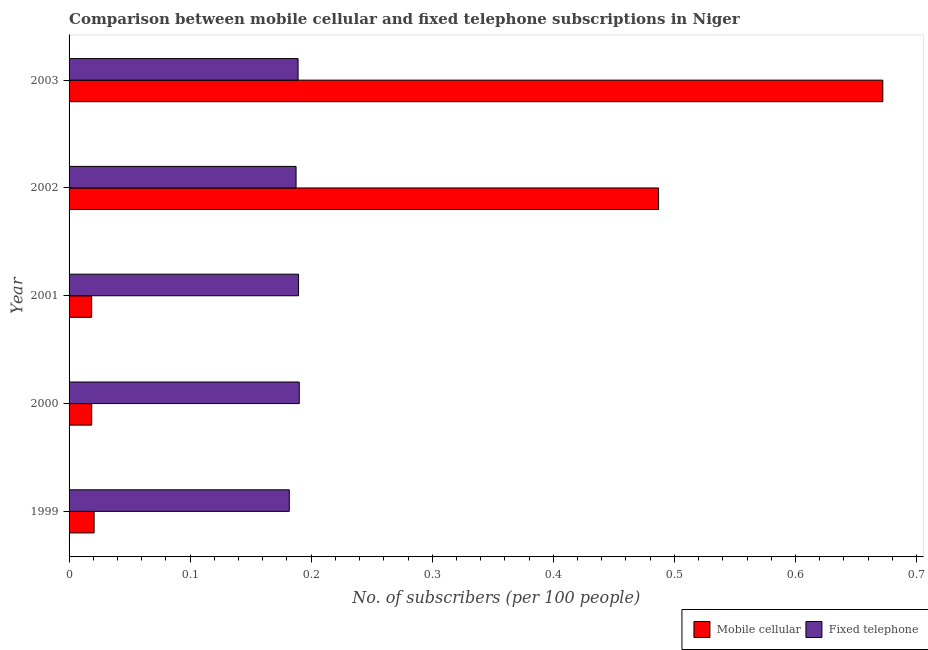How many different coloured bars are there?
Your response must be concise. 2. Are the number of bars per tick equal to the number of legend labels?
Offer a terse response. Yes. Are the number of bars on each tick of the Y-axis equal?
Provide a short and direct response. Yes. How many bars are there on the 2nd tick from the top?
Your response must be concise. 2. In how many cases, is the number of bars for a given year not equal to the number of legend labels?
Make the answer very short. 0. What is the number of fixed telephone subscribers in 2002?
Offer a terse response. 0.19. Across all years, what is the maximum number of fixed telephone subscribers?
Your response must be concise. 0.19. Across all years, what is the minimum number of fixed telephone subscribers?
Your response must be concise. 0.18. In which year was the number of fixed telephone subscribers maximum?
Your answer should be compact. 2000. What is the total number of fixed telephone subscribers in the graph?
Provide a succinct answer. 0.94. What is the difference between the number of fixed telephone subscribers in 1999 and that in 2002?
Your answer should be very brief. -0.01. What is the difference between the number of mobile cellular subscribers in 2002 and the number of fixed telephone subscribers in 2003?
Provide a short and direct response. 0.3. What is the average number of fixed telephone subscribers per year?
Give a very brief answer. 0.19. In the year 1999, what is the difference between the number of mobile cellular subscribers and number of fixed telephone subscribers?
Your answer should be very brief. -0.16. What is the ratio of the number of fixed telephone subscribers in 2001 to that in 2002?
Your response must be concise. 1.01. Is the difference between the number of fixed telephone subscribers in 2000 and 2001 greater than the difference between the number of mobile cellular subscribers in 2000 and 2001?
Your response must be concise. Yes. What is the difference between the highest and the second highest number of fixed telephone subscribers?
Provide a short and direct response. 0. What is the difference between the highest and the lowest number of mobile cellular subscribers?
Offer a terse response. 0.65. In how many years, is the number of fixed telephone subscribers greater than the average number of fixed telephone subscribers taken over all years?
Offer a very short reply. 3. What does the 1st bar from the top in 2003 represents?
Offer a very short reply. Fixed telephone. What does the 2nd bar from the bottom in 2000 represents?
Provide a short and direct response. Fixed telephone. Are all the bars in the graph horizontal?
Make the answer very short. Yes. What is the difference between two consecutive major ticks on the X-axis?
Provide a short and direct response. 0.1. Are the values on the major ticks of X-axis written in scientific E-notation?
Your answer should be compact. No. How many legend labels are there?
Offer a very short reply. 2. What is the title of the graph?
Give a very brief answer. Comparison between mobile cellular and fixed telephone subscriptions in Niger. Does "GDP" appear as one of the legend labels in the graph?
Offer a terse response. No. What is the label or title of the X-axis?
Offer a very short reply. No. of subscribers (per 100 people). What is the label or title of the Y-axis?
Provide a succinct answer. Year. What is the No. of subscribers (per 100 people) in Mobile cellular in 1999?
Give a very brief answer. 0.02. What is the No. of subscribers (per 100 people) in Fixed telephone in 1999?
Provide a succinct answer. 0.18. What is the No. of subscribers (per 100 people) in Mobile cellular in 2000?
Offer a very short reply. 0.02. What is the No. of subscribers (per 100 people) of Fixed telephone in 2000?
Offer a terse response. 0.19. What is the No. of subscribers (per 100 people) of Mobile cellular in 2001?
Offer a terse response. 0.02. What is the No. of subscribers (per 100 people) of Fixed telephone in 2001?
Your answer should be compact. 0.19. What is the No. of subscribers (per 100 people) of Mobile cellular in 2002?
Make the answer very short. 0.49. What is the No. of subscribers (per 100 people) in Fixed telephone in 2002?
Your response must be concise. 0.19. What is the No. of subscribers (per 100 people) in Mobile cellular in 2003?
Provide a succinct answer. 0.67. What is the No. of subscribers (per 100 people) in Fixed telephone in 2003?
Your answer should be very brief. 0.19. Across all years, what is the maximum No. of subscribers (per 100 people) of Mobile cellular?
Provide a succinct answer. 0.67. Across all years, what is the maximum No. of subscribers (per 100 people) of Fixed telephone?
Keep it short and to the point. 0.19. Across all years, what is the minimum No. of subscribers (per 100 people) in Mobile cellular?
Ensure brevity in your answer.  0.02. Across all years, what is the minimum No. of subscribers (per 100 people) in Fixed telephone?
Give a very brief answer. 0.18. What is the total No. of subscribers (per 100 people) in Mobile cellular in the graph?
Ensure brevity in your answer.  1.22. What is the total No. of subscribers (per 100 people) in Fixed telephone in the graph?
Your response must be concise. 0.94. What is the difference between the No. of subscribers (per 100 people) in Mobile cellular in 1999 and that in 2000?
Offer a terse response. 0. What is the difference between the No. of subscribers (per 100 people) in Fixed telephone in 1999 and that in 2000?
Provide a succinct answer. -0.01. What is the difference between the No. of subscribers (per 100 people) in Mobile cellular in 1999 and that in 2001?
Offer a very short reply. 0. What is the difference between the No. of subscribers (per 100 people) of Fixed telephone in 1999 and that in 2001?
Your response must be concise. -0.01. What is the difference between the No. of subscribers (per 100 people) in Mobile cellular in 1999 and that in 2002?
Offer a terse response. -0.47. What is the difference between the No. of subscribers (per 100 people) in Fixed telephone in 1999 and that in 2002?
Give a very brief answer. -0.01. What is the difference between the No. of subscribers (per 100 people) in Mobile cellular in 1999 and that in 2003?
Your answer should be compact. -0.65. What is the difference between the No. of subscribers (per 100 people) in Fixed telephone in 1999 and that in 2003?
Provide a succinct answer. -0.01. What is the difference between the No. of subscribers (per 100 people) in Mobile cellular in 2000 and that in 2001?
Your answer should be very brief. 0. What is the difference between the No. of subscribers (per 100 people) in Fixed telephone in 2000 and that in 2001?
Provide a short and direct response. 0. What is the difference between the No. of subscribers (per 100 people) in Mobile cellular in 2000 and that in 2002?
Offer a very short reply. -0.47. What is the difference between the No. of subscribers (per 100 people) of Fixed telephone in 2000 and that in 2002?
Offer a very short reply. 0. What is the difference between the No. of subscribers (per 100 people) of Mobile cellular in 2000 and that in 2003?
Give a very brief answer. -0.65. What is the difference between the No. of subscribers (per 100 people) of Mobile cellular in 2001 and that in 2002?
Keep it short and to the point. -0.47. What is the difference between the No. of subscribers (per 100 people) of Fixed telephone in 2001 and that in 2002?
Provide a short and direct response. 0. What is the difference between the No. of subscribers (per 100 people) of Mobile cellular in 2001 and that in 2003?
Offer a terse response. -0.65. What is the difference between the No. of subscribers (per 100 people) of Mobile cellular in 2002 and that in 2003?
Offer a terse response. -0.19. What is the difference between the No. of subscribers (per 100 people) of Fixed telephone in 2002 and that in 2003?
Your answer should be very brief. -0. What is the difference between the No. of subscribers (per 100 people) in Mobile cellular in 1999 and the No. of subscribers (per 100 people) in Fixed telephone in 2000?
Your response must be concise. -0.17. What is the difference between the No. of subscribers (per 100 people) of Mobile cellular in 1999 and the No. of subscribers (per 100 people) of Fixed telephone in 2001?
Make the answer very short. -0.17. What is the difference between the No. of subscribers (per 100 people) of Mobile cellular in 1999 and the No. of subscribers (per 100 people) of Fixed telephone in 2002?
Offer a very short reply. -0.17. What is the difference between the No. of subscribers (per 100 people) in Mobile cellular in 1999 and the No. of subscribers (per 100 people) in Fixed telephone in 2003?
Offer a terse response. -0.17. What is the difference between the No. of subscribers (per 100 people) of Mobile cellular in 2000 and the No. of subscribers (per 100 people) of Fixed telephone in 2001?
Provide a short and direct response. -0.17. What is the difference between the No. of subscribers (per 100 people) in Mobile cellular in 2000 and the No. of subscribers (per 100 people) in Fixed telephone in 2002?
Make the answer very short. -0.17. What is the difference between the No. of subscribers (per 100 people) in Mobile cellular in 2000 and the No. of subscribers (per 100 people) in Fixed telephone in 2003?
Make the answer very short. -0.17. What is the difference between the No. of subscribers (per 100 people) in Mobile cellular in 2001 and the No. of subscribers (per 100 people) in Fixed telephone in 2002?
Provide a succinct answer. -0.17. What is the difference between the No. of subscribers (per 100 people) of Mobile cellular in 2001 and the No. of subscribers (per 100 people) of Fixed telephone in 2003?
Provide a short and direct response. -0.17. What is the difference between the No. of subscribers (per 100 people) in Mobile cellular in 2002 and the No. of subscribers (per 100 people) in Fixed telephone in 2003?
Provide a short and direct response. 0.3. What is the average No. of subscribers (per 100 people) in Mobile cellular per year?
Keep it short and to the point. 0.24. What is the average No. of subscribers (per 100 people) in Fixed telephone per year?
Ensure brevity in your answer.  0.19. In the year 1999, what is the difference between the No. of subscribers (per 100 people) in Mobile cellular and No. of subscribers (per 100 people) in Fixed telephone?
Your answer should be very brief. -0.16. In the year 2000, what is the difference between the No. of subscribers (per 100 people) of Mobile cellular and No. of subscribers (per 100 people) of Fixed telephone?
Provide a succinct answer. -0.17. In the year 2001, what is the difference between the No. of subscribers (per 100 people) in Mobile cellular and No. of subscribers (per 100 people) in Fixed telephone?
Give a very brief answer. -0.17. In the year 2002, what is the difference between the No. of subscribers (per 100 people) in Mobile cellular and No. of subscribers (per 100 people) in Fixed telephone?
Your response must be concise. 0.3. In the year 2003, what is the difference between the No. of subscribers (per 100 people) in Mobile cellular and No. of subscribers (per 100 people) in Fixed telephone?
Your answer should be compact. 0.48. What is the ratio of the No. of subscribers (per 100 people) of Mobile cellular in 1999 to that in 2000?
Offer a terse response. 1.11. What is the ratio of the No. of subscribers (per 100 people) of Fixed telephone in 1999 to that in 2000?
Make the answer very short. 0.96. What is the ratio of the No. of subscribers (per 100 people) of Mobile cellular in 1999 to that in 2001?
Give a very brief answer. 1.11. What is the ratio of the No. of subscribers (per 100 people) of Fixed telephone in 1999 to that in 2001?
Make the answer very short. 0.96. What is the ratio of the No. of subscribers (per 100 people) in Mobile cellular in 1999 to that in 2002?
Offer a very short reply. 0.04. What is the ratio of the No. of subscribers (per 100 people) of Fixed telephone in 1999 to that in 2002?
Your response must be concise. 0.97. What is the ratio of the No. of subscribers (per 100 people) of Mobile cellular in 1999 to that in 2003?
Provide a short and direct response. 0.03. What is the ratio of the No. of subscribers (per 100 people) of Fixed telephone in 1999 to that in 2003?
Your response must be concise. 0.96. What is the ratio of the No. of subscribers (per 100 people) of Mobile cellular in 2000 to that in 2001?
Keep it short and to the point. 1. What is the ratio of the No. of subscribers (per 100 people) in Mobile cellular in 2000 to that in 2002?
Offer a very short reply. 0.04. What is the ratio of the No. of subscribers (per 100 people) in Fixed telephone in 2000 to that in 2002?
Provide a succinct answer. 1.01. What is the ratio of the No. of subscribers (per 100 people) of Mobile cellular in 2000 to that in 2003?
Provide a succinct answer. 0.03. What is the ratio of the No. of subscribers (per 100 people) in Mobile cellular in 2001 to that in 2002?
Your answer should be compact. 0.04. What is the ratio of the No. of subscribers (per 100 people) of Fixed telephone in 2001 to that in 2002?
Provide a succinct answer. 1.01. What is the ratio of the No. of subscribers (per 100 people) of Mobile cellular in 2001 to that in 2003?
Your answer should be compact. 0.03. What is the ratio of the No. of subscribers (per 100 people) of Mobile cellular in 2002 to that in 2003?
Your answer should be compact. 0.72. What is the ratio of the No. of subscribers (per 100 people) in Fixed telephone in 2002 to that in 2003?
Offer a terse response. 0.99. What is the difference between the highest and the second highest No. of subscribers (per 100 people) of Mobile cellular?
Your answer should be very brief. 0.19. What is the difference between the highest and the second highest No. of subscribers (per 100 people) in Fixed telephone?
Offer a very short reply. 0. What is the difference between the highest and the lowest No. of subscribers (per 100 people) of Mobile cellular?
Keep it short and to the point. 0.65. What is the difference between the highest and the lowest No. of subscribers (per 100 people) in Fixed telephone?
Your answer should be very brief. 0.01. 